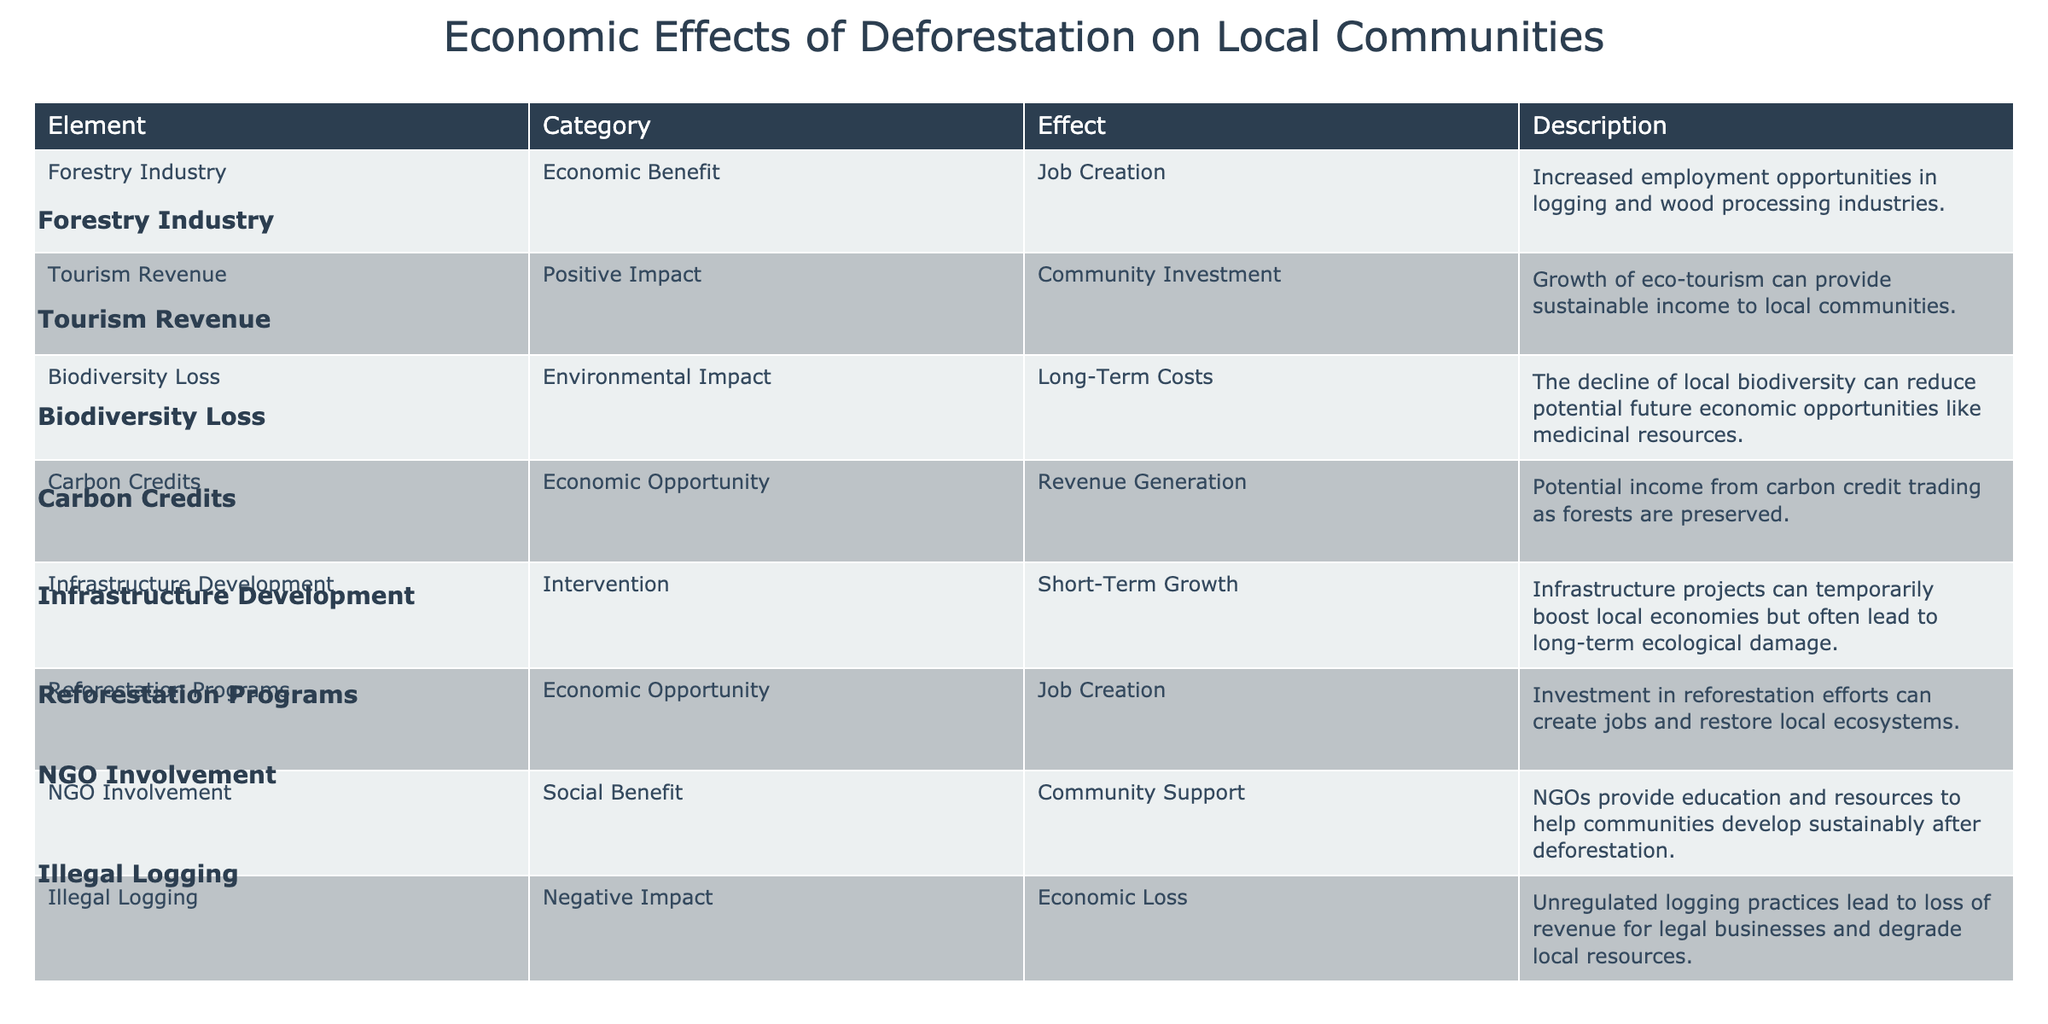What is the economic benefit related to the forestry industry? The table lists "Job Creation" as the economic benefit associated with the forestry industry in the first row.
Answer: Job Creation Which economic opportunity is linked to carbon credits? The entry for carbon credits states that they offer "Revenue Generation" as an economic opportunity.
Answer: Revenue Generation Is tourism revenue considered a positive impact on local communities? The table explicitly describes tourism revenue as a "Positive Impact" under the category of "Community Investment."
Answer: Yes What negative impact does illegal logging have on local economies? According to the table, illegal logging leads to "Economic Loss," which signifies a negative impact on local economies.
Answer: Economic Loss What are the long-term costs associated with biodiversity loss? The table indicates that biodiversity loss can lead to "Long-Term Costs," particularly by reducing potentials for resources such as medicines.
Answer: Long-Term Costs How many economic opportunities are listed in the table? The table provides two entries categorized as "Economic Opportunity" for carbon credits and reforestation programs, making a total of two economic opportunities.
Answer: 2 Do all effects listed in the table have a positive outcome for local communities? The table includes both positive impacts (like tourism revenue) and negative impacts (like illegal logging), so not all effects are positive.
Answer: No Which interventions can temporarily boost local economies according to the table? The table identifies "Infrastructure Development" as an intervention that may cause short-term economic growth, although it may have adverse long-term ecological effects.
Answer: Infrastructure Development What is the impact of reforestation programs in the context of job creation? The table notes that reforestation programs create "Job Creation," illustrating their positive impact on employment in local communities.
Answer: Job Creation 